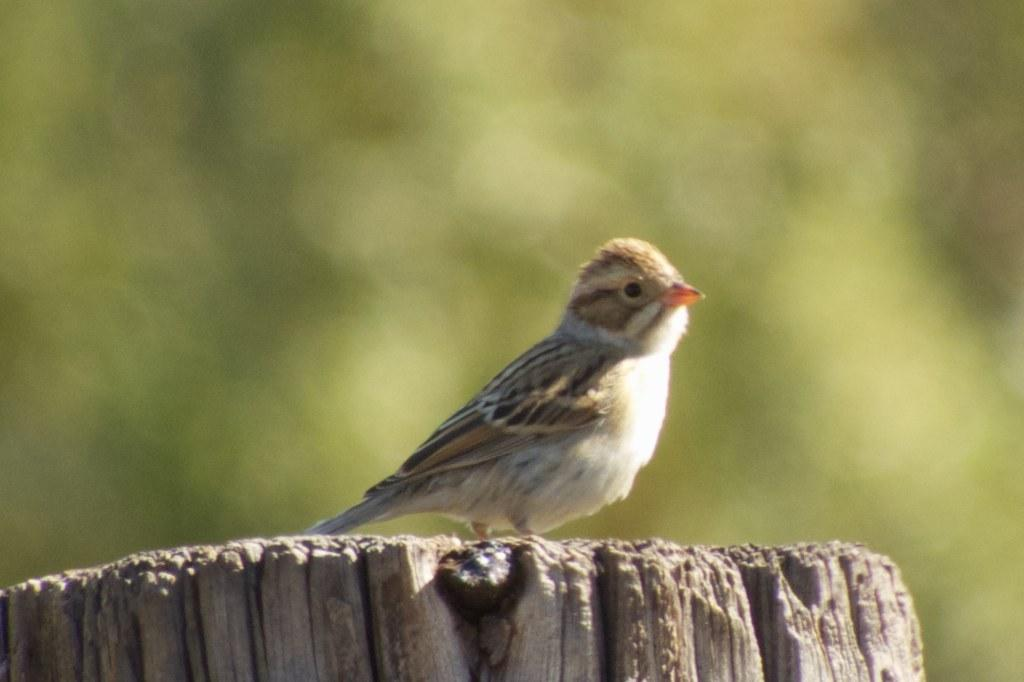What type of animal can be seen in the image? There is a bird in the image. Where is the bird located? The bird is on a tree trunk. Can you describe the background of the image? The background of the image is blurry. What type of payment is the bird receiving in the image? There is no payment present in the image, as it features a bird on a tree trunk with a blurry background. 